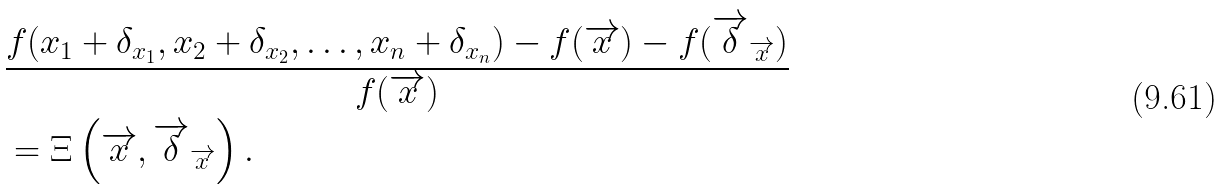Convert formula to latex. <formula><loc_0><loc_0><loc_500><loc_500>& \frac { f ( x _ { 1 } + \delta _ { x _ { 1 } } , x _ { 2 } + \delta _ { x _ { 2 } } , \dots , x _ { n } + \delta _ { x _ { n } } ) - f ( \overrightarrow { x } ) - f ( \overrightarrow { \delta } _ { \overrightarrow { x } } ) } { f ( \overrightarrow { x } ) } \\ & = \Xi \left ( \overrightarrow { x } , \overrightarrow { \delta } _ { \overrightarrow { x } } \right ) .</formula> 